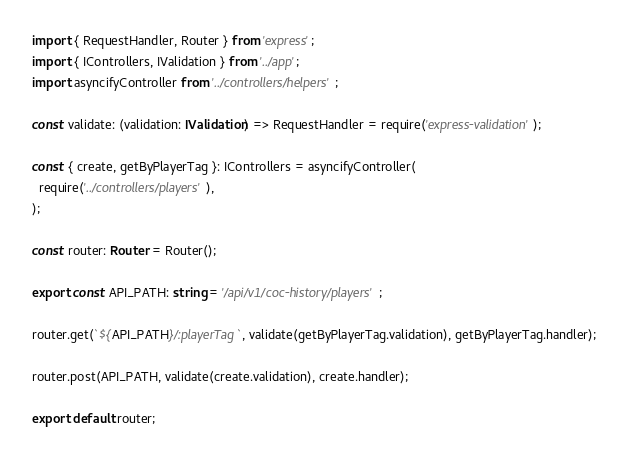Convert code to text. <code><loc_0><loc_0><loc_500><loc_500><_TypeScript_>import { RequestHandler, Router } from 'express';
import { IControllers, IValidation } from '../app';
import asyncifyController from '../controllers/helpers';

const validate: (validation: IValidation) => RequestHandler = require('express-validation');

const { create, getByPlayerTag }: IControllers = asyncifyController(
  require('../controllers/players'),
);

const router: Router = Router();

export const API_PATH: string = '/api/v1/coc-history/players';

router.get(`${API_PATH}/:playerTag`, validate(getByPlayerTag.validation), getByPlayerTag.handler);

router.post(API_PATH, validate(create.validation), create.handler);

export default router;
</code> 